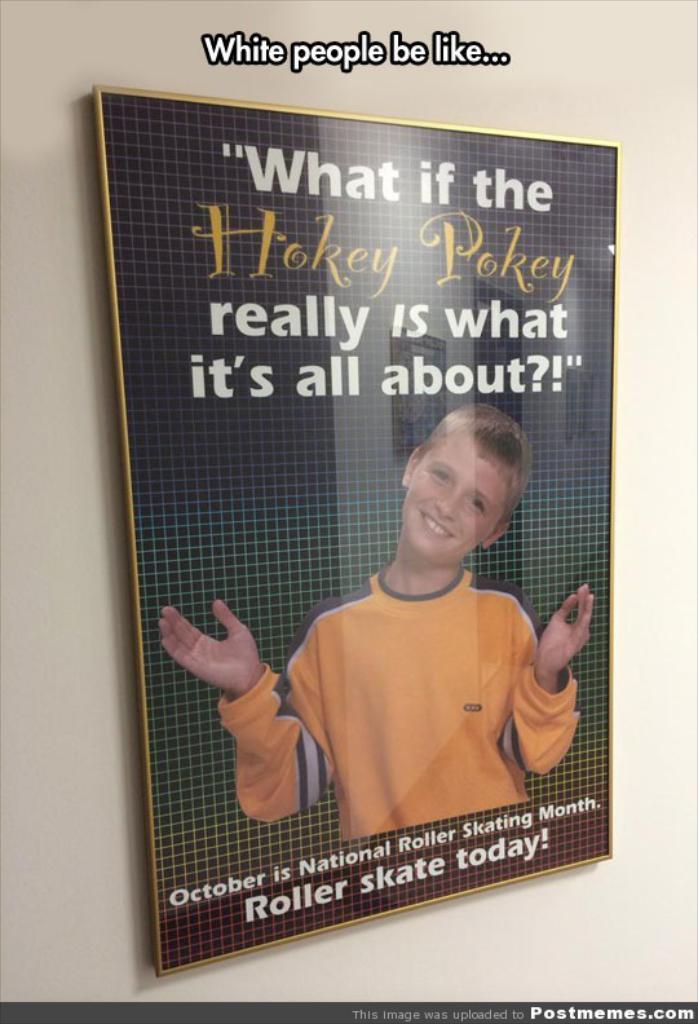Provide a one-sentence caption for the provided image. According to a poster October is National Roller Skating Month. 